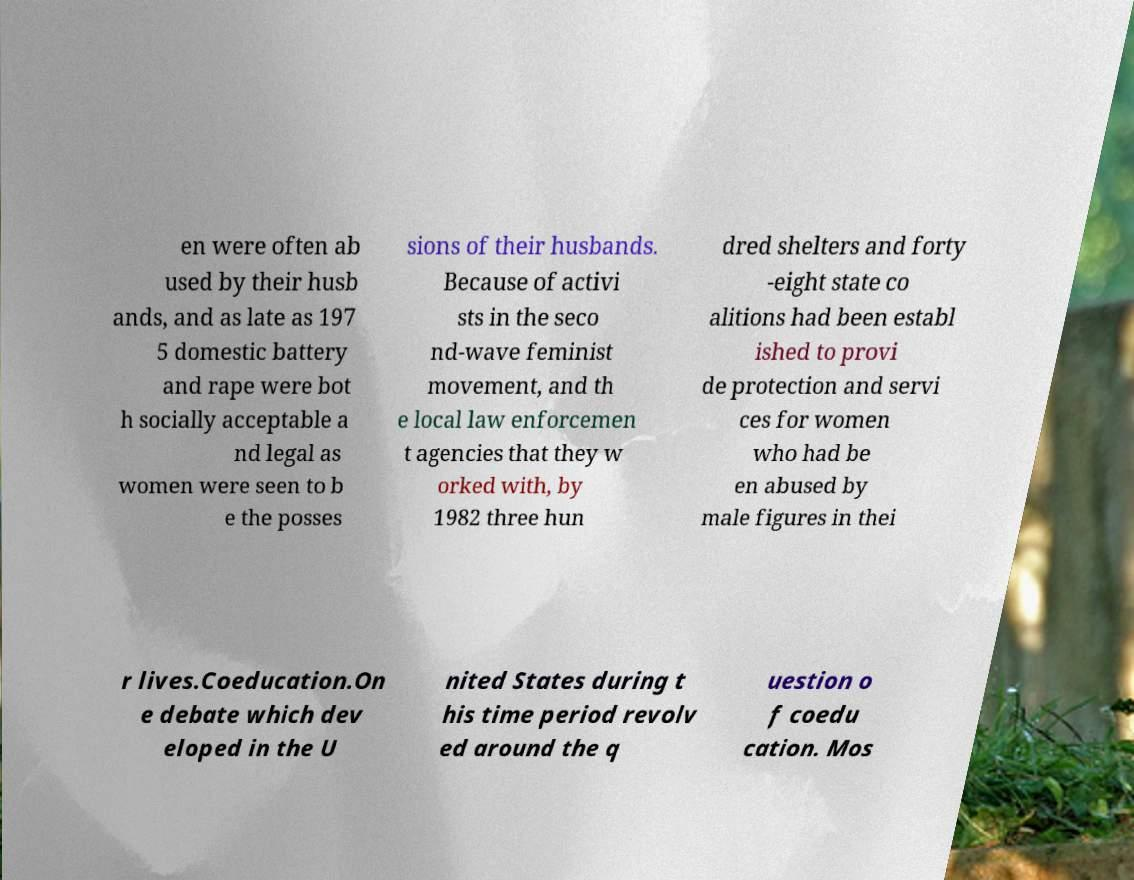Could you assist in decoding the text presented in this image and type it out clearly? en were often ab used by their husb ands, and as late as 197 5 domestic battery and rape were bot h socially acceptable a nd legal as women were seen to b e the posses sions of their husbands. Because of activi sts in the seco nd-wave feminist movement, and th e local law enforcemen t agencies that they w orked with, by 1982 three hun dred shelters and forty -eight state co alitions had been establ ished to provi de protection and servi ces for women who had be en abused by male figures in thei r lives.Coeducation.On e debate which dev eloped in the U nited States during t his time period revolv ed around the q uestion o f coedu cation. Mos 